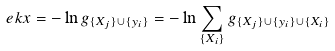<formula> <loc_0><loc_0><loc_500><loc_500>\ e k x = - \ln g _ { \{ X _ { j } \} \cup \{ y _ { i } \} } = - \ln \sum _ { \{ X _ { i } \} } g _ { \{ X _ { j } \} \cup \{ y _ { i } \} \cup \{ X _ { i } \} }</formula> 